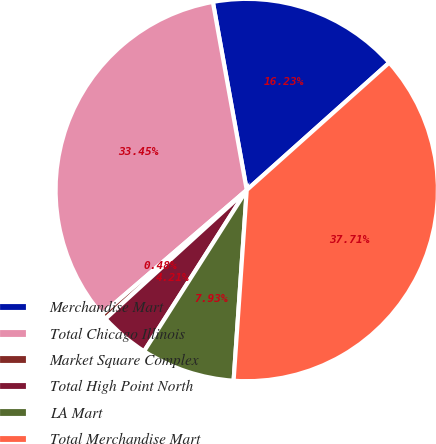<chart> <loc_0><loc_0><loc_500><loc_500><pie_chart><fcel>Merchandise Mart<fcel>Total Chicago Illinois<fcel>Market Square Complex<fcel>Total High Point North<fcel>LA Mart<fcel>Total Merchandise Mart<nl><fcel>16.23%<fcel>33.45%<fcel>0.48%<fcel>4.21%<fcel>7.93%<fcel>37.71%<nl></chart> 